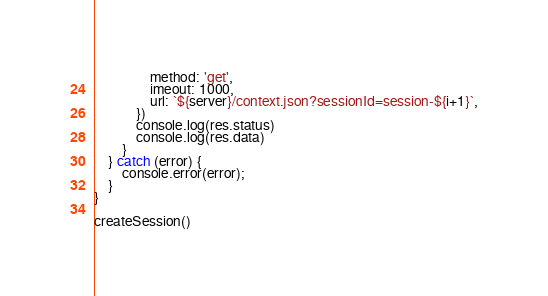<code> <loc_0><loc_0><loc_500><loc_500><_JavaScript_>                method: 'get',
                imeout: 1000,
                url: `${server}/context.json?sessionId=session-${i+1}`,
            })
            console.log(res.status)
            console.log(res.data)
        }
    } catch (error) {
        console.error(error);
    }
}

createSession()
</code> 